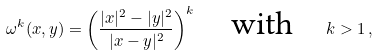<formula> <loc_0><loc_0><loc_500><loc_500>\omega ^ { k } ( x , y ) = \left ( \frac { | x | ^ { 2 } - | y | ^ { 2 } } { | x - y | ^ { 2 } } \right ) ^ { k } \quad \text {with} \quad k > 1 \, ,</formula> 